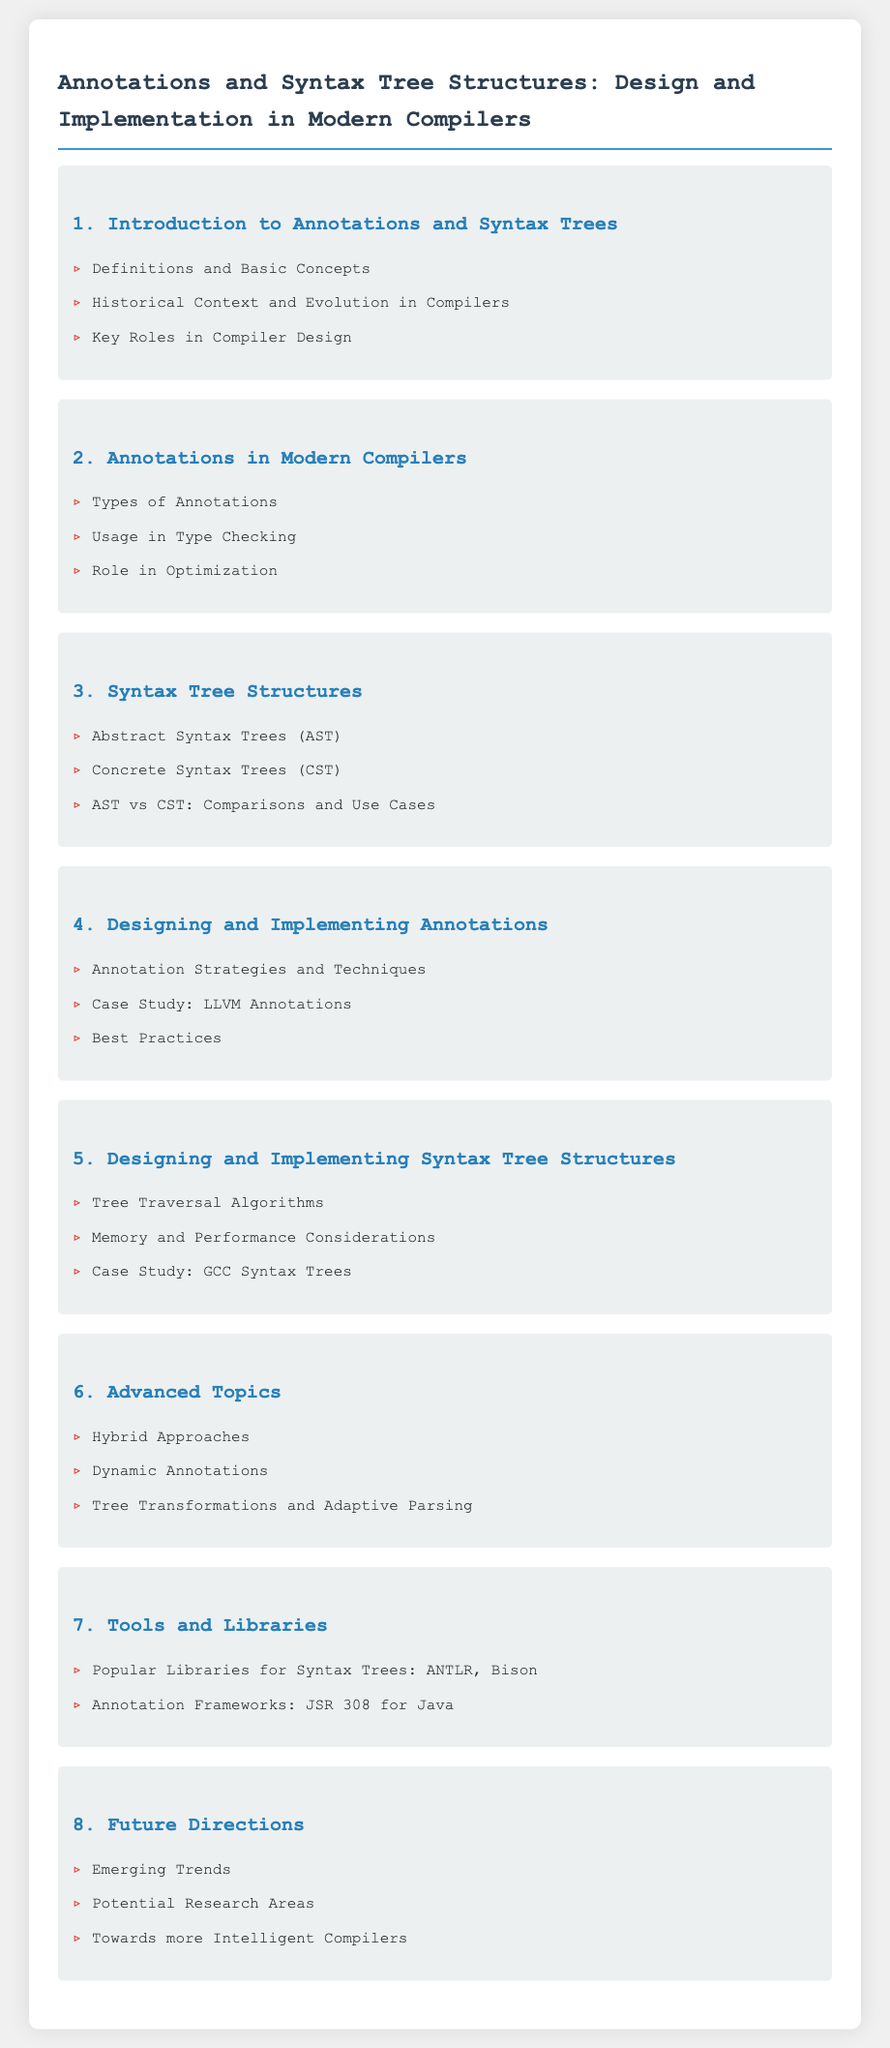What is the first section title? The first section of the document introduces the topic of Annotations and Syntax Trees, and the title is mentioned explicitly.
Answer: Introduction to Annotations and Syntax Trees How many types of annotations are discussed? The document lists the types of annotations as a specific bullet point in the second section, indicating that it includes different categories.
Answer: 1 Which case study is mentioned for annotations? The document explicitly names a case study related to annotations in the fourth section, identifying the specific example that is discussed.
Answer: LLVM Annotations What is the subject of the fifth section? The fifth section's title provides insight into its content regarding the design and implementation aspects of syntax trees in modern compilers.
Answer: Designing and Implementing Syntax Tree Structures Name one popular library mentioned for syntax trees. The document lists tools and libraries in the seventh section, specifically mentioning popular libraries that are used for syntax tree structures.
Answer: ANTLR How many advanced topics are listed in section six? In the sixth section, the list of advanced topics is explicitly provided, indicating exactly how many are covered.
Answer: 3 